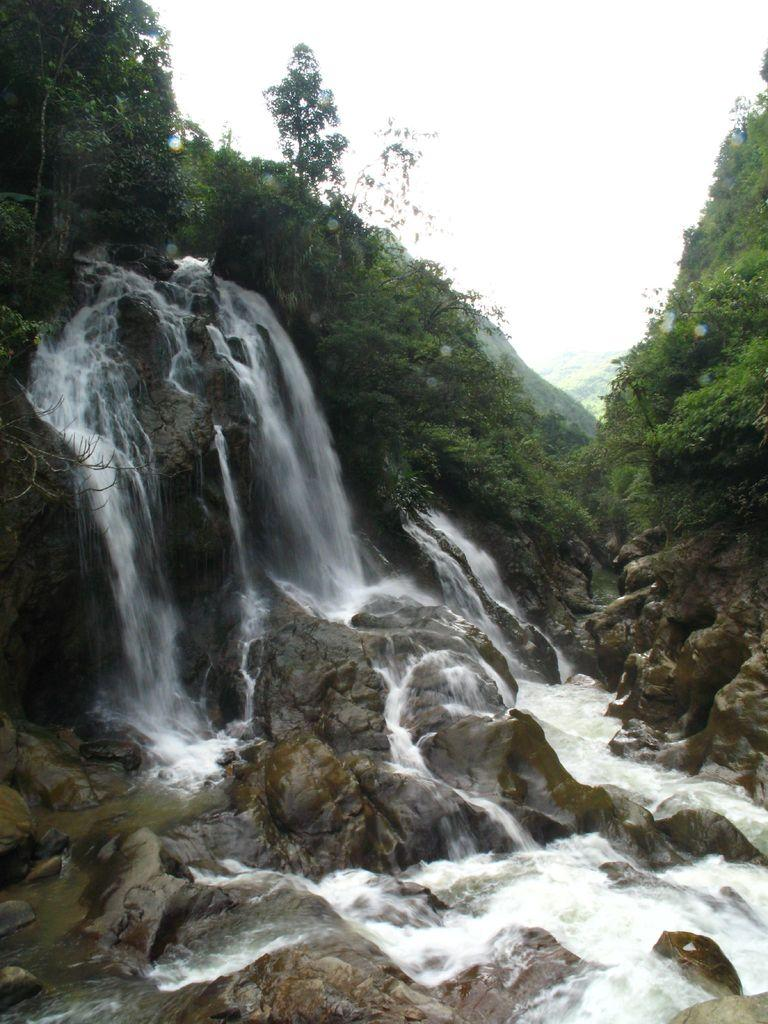What type of natural features can be seen in the image? There are rocks, waterfalls, and trees in the image. What is visible in the background of the image? The sky is visible in the background of the image. What type of sponge is being used to clean the rocks in the image? There is no sponge present in the image, and the rocks are not being cleaned. 